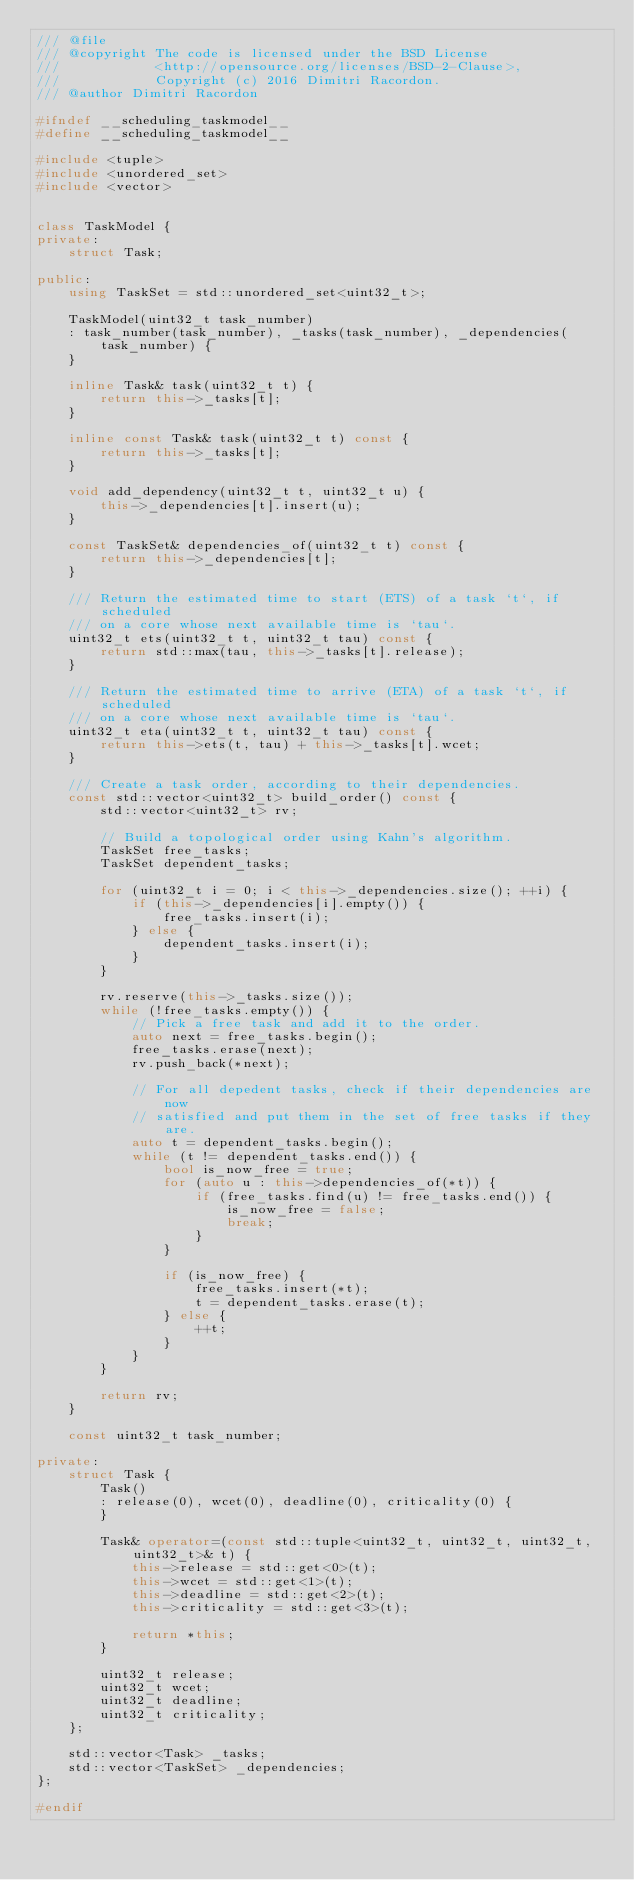Convert code to text. <code><loc_0><loc_0><loc_500><loc_500><_C++_>/// @file
/// @copyright The code is licensed under the BSD License
///            <http://opensource.org/licenses/BSD-2-Clause>,
///            Copyright (c) 2016 Dimitri Racordon.
/// @author Dimitri Racordon

#ifndef __scheduling_taskmodel__
#define __scheduling_taskmodel__

#include <tuple>
#include <unordered_set>
#include <vector>


class TaskModel {
private:
    struct Task;

public:
    using TaskSet = std::unordered_set<uint32_t>;

    TaskModel(uint32_t task_number)
    : task_number(task_number), _tasks(task_number), _dependencies(task_number) {
    }

    inline Task& task(uint32_t t) {
        return this->_tasks[t];
    }

    inline const Task& task(uint32_t t) const {
        return this->_tasks[t];
    }

    void add_dependency(uint32_t t, uint32_t u) {
        this->_dependencies[t].insert(u);
    }

    const TaskSet& dependencies_of(uint32_t t) const {
        return this->_dependencies[t];
    }

    /// Return the estimated time to start (ETS) of a task `t`, if scheduled
    /// on a core whose next available time is `tau`.
    uint32_t ets(uint32_t t, uint32_t tau) const {
        return std::max(tau, this->_tasks[t].release);
    }
    
    /// Return the estimated time to arrive (ETA) of a task `t`, if scheduled
    /// on a core whose next available time is `tau`.
    uint32_t eta(uint32_t t, uint32_t tau) const {
        return this->ets(t, tau) + this->_tasks[t].wcet;
    }

    /// Create a task order, according to their dependencies.
    const std::vector<uint32_t> build_order() const {
        std::vector<uint32_t> rv;

        // Build a topological order using Kahn's algorithm.
        TaskSet free_tasks;
        TaskSet dependent_tasks;

        for (uint32_t i = 0; i < this->_dependencies.size(); ++i) {
            if (this->_dependencies[i].empty()) {
                free_tasks.insert(i);
            } else {
                dependent_tasks.insert(i);
            }
        }

        rv.reserve(this->_tasks.size());
        while (!free_tasks.empty()) {
            // Pick a free task and add it to the order.
            auto next = free_tasks.begin();
            free_tasks.erase(next);
            rv.push_back(*next);

            // For all depedent tasks, check if their dependencies are now
            // satisfied and put them in the set of free tasks if they are.
            auto t = dependent_tasks.begin();
            while (t != dependent_tasks.end()) {
                bool is_now_free = true;
                for (auto u : this->dependencies_of(*t)) {
                    if (free_tasks.find(u) != free_tasks.end()) {
                        is_now_free = false;
                        break;
                    }
                }

                if (is_now_free) {
                    free_tasks.insert(*t);
                    t = dependent_tasks.erase(t);
                } else {
                    ++t;
                }
            }
        }

        return rv;
    }

    const uint32_t task_number;

private:
    struct Task {
        Task()
        : release(0), wcet(0), deadline(0), criticality(0) {
        }

        Task& operator=(const std::tuple<uint32_t, uint32_t, uint32_t, uint32_t>& t) {
            this->release = std::get<0>(t);
            this->wcet = std::get<1>(t);
            this->deadline = std::get<2>(t);
            this->criticality = std::get<3>(t);

            return *this;
        }

        uint32_t release;
        uint32_t wcet;
        uint32_t deadline;
        uint32_t criticality;
    };

    std::vector<Task> _tasks;
    std::vector<TaskSet> _dependencies;
};

#endif
</code> 